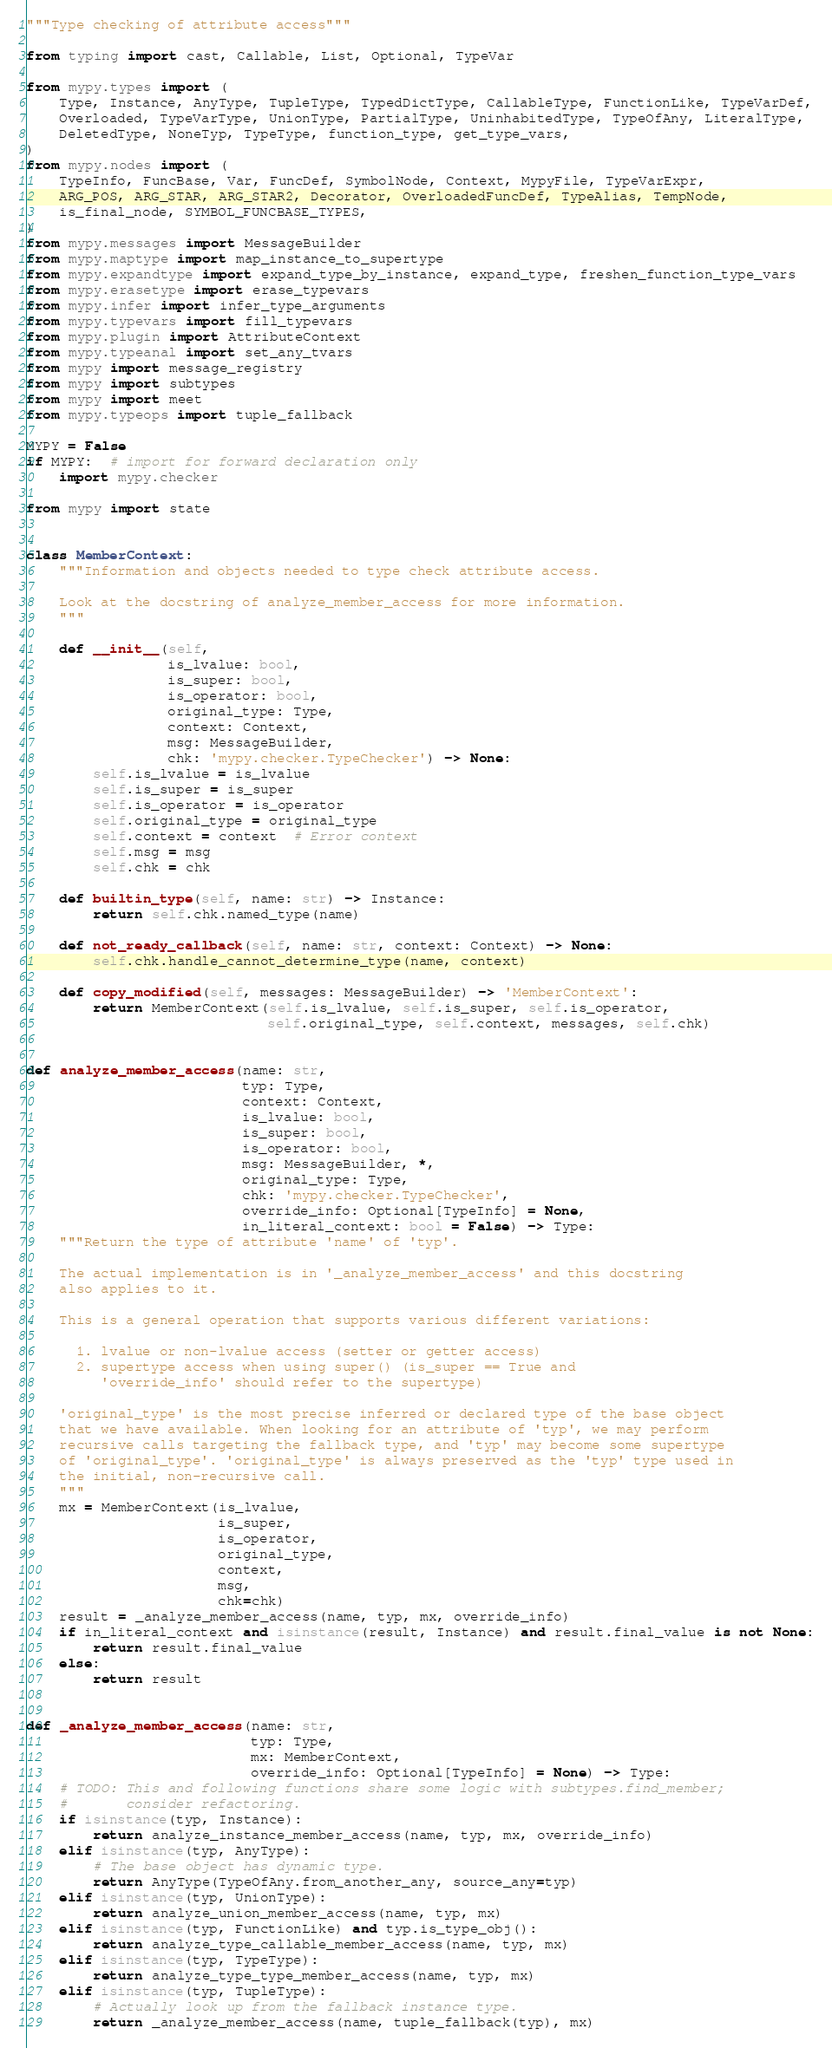Convert code to text. <code><loc_0><loc_0><loc_500><loc_500><_Python_>"""Type checking of attribute access"""

from typing import cast, Callable, List, Optional, TypeVar

from mypy.types import (
    Type, Instance, AnyType, TupleType, TypedDictType, CallableType, FunctionLike, TypeVarDef,
    Overloaded, TypeVarType, UnionType, PartialType, UninhabitedType, TypeOfAny, LiteralType,
    DeletedType, NoneTyp, TypeType, function_type, get_type_vars,
)
from mypy.nodes import (
    TypeInfo, FuncBase, Var, FuncDef, SymbolNode, Context, MypyFile, TypeVarExpr,
    ARG_POS, ARG_STAR, ARG_STAR2, Decorator, OverloadedFuncDef, TypeAlias, TempNode,
    is_final_node, SYMBOL_FUNCBASE_TYPES,
)
from mypy.messages import MessageBuilder
from mypy.maptype import map_instance_to_supertype
from mypy.expandtype import expand_type_by_instance, expand_type, freshen_function_type_vars
from mypy.erasetype import erase_typevars
from mypy.infer import infer_type_arguments
from mypy.typevars import fill_typevars
from mypy.plugin import AttributeContext
from mypy.typeanal import set_any_tvars
from mypy import message_registry
from mypy import subtypes
from mypy import meet
from mypy.typeops import tuple_fallback

MYPY = False
if MYPY:  # import for forward declaration only
    import mypy.checker

from mypy import state


class MemberContext:
    """Information and objects needed to type check attribute access.

    Look at the docstring of analyze_member_access for more information.
    """

    def __init__(self,
                 is_lvalue: bool,
                 is_super: bool,
                 is_operator: bool,
                 original_type: Type,
                 context: Context,
                 msg: MessageBuilder,
                 chk: 'mypy.checker.TypeChecker') -> None:
        self.is_lvalue = is_lvalue
        self.is_super = is_super
        self.is_operator = is_operator
        self.original_type = original_type
        self.context = context  # Error context
        self.msg = msg
        self.chk = chk

    def builtin_type(self, name: str) -> Instance:
        return self.chk.named_type(name)

    def not_ready_callback(self, name: str, context: Context) -> None:
        self.chk.handle_cannot_determine_type(name, context)

    def copy_modified(self, messages: MessageBuilder) -> 'MemberContext':
        return MemberContext(self.is_lvalue, self.is_super, self.is_operator,
                             self.original_type, self.context, messages, self.chk)


def analyze_member_access(name: str,
                          typ: Type,
                          context: Context,
                          is_lvalue: bool,
                          is_super: bool,
                          is_operator: bool,
                          msg: MessageBuilder, *,
                          original_type: Type,
                          chk: 'mypy.checker.TypeChecker',
                          override_info: Optional[TypeInfo] = None,
                          in_literal_context: bool = False) -> Type:
    """Return the type of attribute 'name' of 'typ'.

    The actual implementation is in '_analyze_member_access' and this docstring
    also applies to it.

    This is a general operation that supports various different variations:

      1. lvalue or non-lvalue access (setter or getter access)
      2. supertype access when using super() (is_super == True and
         'override_info' should refer to the supertype)

    'original_type' is the most precise inferred or declared type of the base object
    that we have available. When looking for an attribute of 'typ', we may perform
    recursive calls targeting the fallback type, and 'typ' may become some supertype
    of 'original_type'. 'original_type' is always preserved as the 'typ' type used in
    the initial, non-recursive call.
    """
    mx = MemberContext(is_lvalue,
                       is_super,
                       is_operator,
                       original_type,
                       context,
                       msg,
                       chk=chk)
    result = _analyze_member_access(name, typ, mx, override_info)
    if in_literal_context and isinstance(result, Instance) and result.final_value is not None:
        return result.final_value
    else:
        return result


def _analyze_member_access(name: str,
                           typ: Type,
                           mx: MemberContext,
                           override_info: Optional[TypeInfo] = None) -> Type:
    # TODO: This and following functions share some logic with subtypes.find_member;
    #       consider refactoring.
    if isinstance(typ, Instance):
        return analyze_instance_member_access(name, typ, mx, override_info)
    elif isinstance(typ, AnyType):
        # The base object has dynamic type.
        return AnyType(TypeOfAny.from_another_any, source_any=typ)
    elif isinstance(typ, UnionType):
        return analyze_union_member_access(name, typ, mx)
    elif isinstance(typ, FunctionLike) and typ.is_type_obj():
        return analyze_type_callable_member_access(name, typ, mx)
    elif isinstance(typ, TypeType):
        return analyze_type_type_member_access(name, typ, mx)
    elif isinstance(typ, TupleType):
        # Actually look up from the fallback instance type.
        return _analyze_member_access(name, tuple_fallback(typ), mx)</code> 